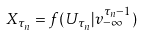<formula> <loc_0><loc_0><loc_500><loc_500>X _ { \tau _ { n } } = f ( U _ { \tau _ { n } } | v _ { - \infty } ^ { \tau _ { n } - 1 } )</formula> 